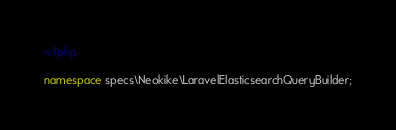Convert code to text. <code><loc_0><loc_0><loc_500><loc_500><_PHP_><?php

namespace specs\Neokike\LaravelElasticsearchQueryBuilder;
</code> 